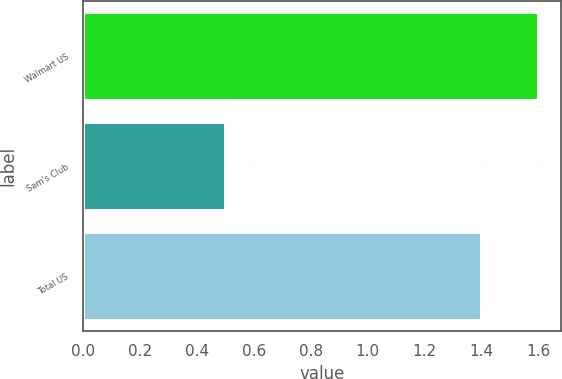Convert chart to OTSL. <chart><loc_0><loc_0><loc_500><loc_500><bar_chart><fcel>Walmart US<fcel>Sam's Club<fcel>Total US<nl><fcel>1.6<fcel>0.5<fcel>1.4<nl></chart> 